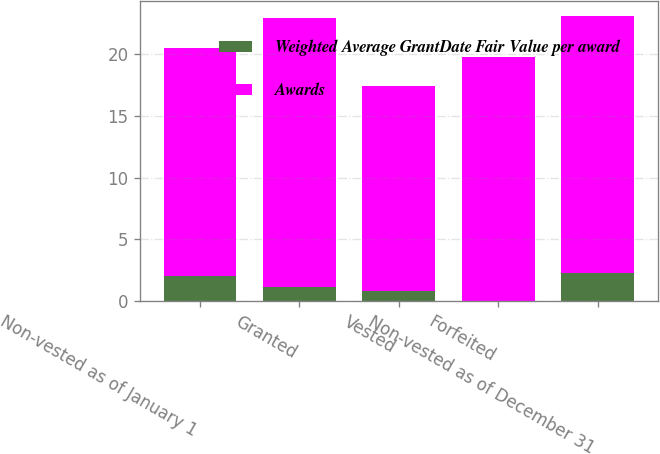Convert chart to OTSL. <chart><loc_0><loc_0><loc_500><loc_500><stacked_bar_chart><ecel><fcel>Non-vested as of January 1<fcel>Granted<fcel>Vested<fcel>Forfeited<fcel>Non-vested as of December 31<nl><fcel>Weighted Average GrantDate Fair Value per award<fcel>2<fcel>1.1<fcel>0.8<fcel>0<fcel>2.3<nl><fcel>Awards<fcel>18.53<fcel>21.87<fcel>16.64<fcel>19.8<fcel>20.84<nl></chart> 